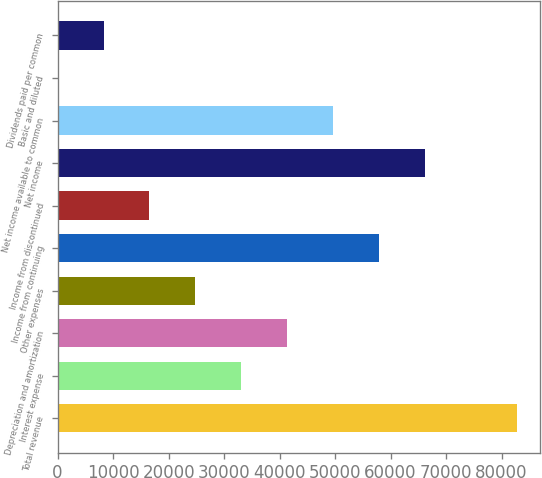Convert chart. <chart><loc_0><loc_0><loc_500><loc_500><bar_chart><fcel>Total revenue<fcel>Interest expense<fcel>Depreciation and amortization<fcel>Other expenses<fcel>Income from continuing<fcel>Income from discontinued<fcel>Net income<fcel>Net income available to common<fcel>Basic and diluted<fcel>Dividends paid per common<nl><fcel>82726<fcel>33090.6<fcel>41363.1<fcel>24818<fcel>57908.3<fcel>16545.4<fcel>66180.8<fcel>49635.7<fcel>0.27<fcel>8272.84<nl></chart> 